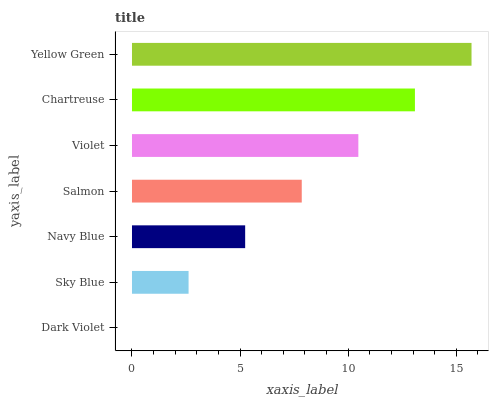Is Dark Violet the minimum?
Answer yes or no. Yes. Is Yellow Green the maximum?
Answer yes or no. Yes. Is Sky Blue the minimum?
Answer yes or no. No. Is Sky Blue the maximum?
Answer yes or no. No. Is Sky Blue greater than Dark Violet?
Answer yes or no. Yes. Is Dark Violet less than Sky Blue?
Answer yes or no. Yes. Is Dark Violet greater than Sky Blue?
Answer yes or no. No. Is Sky Blue less than Dark Violet?
Answer yes or no. No. Is Salmon the high median?
Answer yes or no. Yes. Is Salmon the low median?
Answer yes or no. Yes. Is Dark Violet the high median?
Answer yes or no. No. Is Navy Blue the low median?
Answer yes or no. No. 